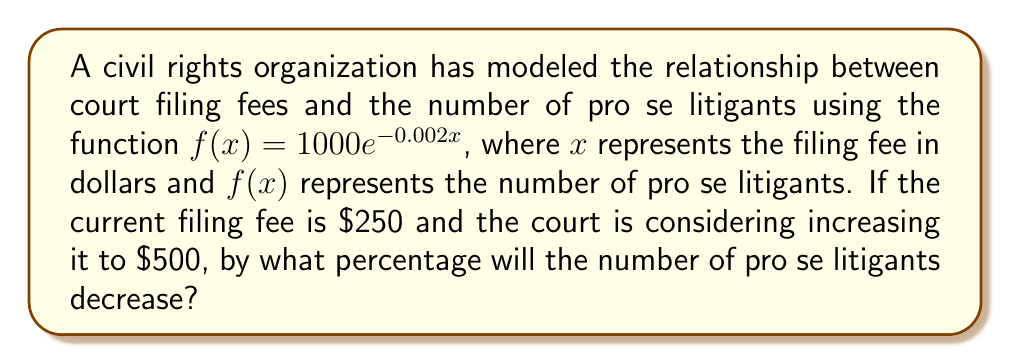Can you answer this question? 1. Calculate the number of pro se litigants at the current fee:
   $f(250) = 1000e^{-0.002(250)} = 1000e^{-0.5} \approx 606.53$

2. Calculate the number of pro se litigants at the proposed fee:
   $f(500) = 1000e^{-0.002(500)} = 1000e^{-1} \approx 367.88$

3. Calculate the difference in the number of pro se litigants:
   $606.53 - 367.88 = 238.65$

4. Calculate the percentage decrease:
   Percentage decrease = $\frac{\text{Decrease}}{\text{Original}} \times 100\%$
   $= \frac{238.65}{606.53} \times 100\% \approx 39.35\%$

Therefore, the number of pro se litigants will decrease by approximately 39.35%.
Answer: 39.35% 